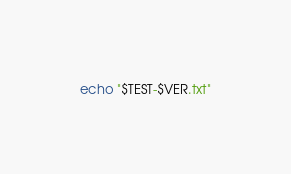Convert code to text. <code><loc_0><loc_0><loc_500><loc_500><_Bash_>echo "$TEST-$VER.txt"
</code> 